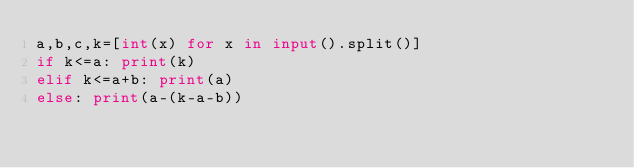Convert code to text. <code><loc_0><loc_0><loc_500><loc_500><_Python_>a,b,c,k=[int(x) for x in input().split()]
if k<=a: print(k)
elif k<=a+b: print(a)
else: print(a-(k-a-b))</code> 